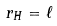Convert formula to latex. <formula><loc_0><loc_0><loc_500><loc_500>r _ { H } = \ell</formula> 